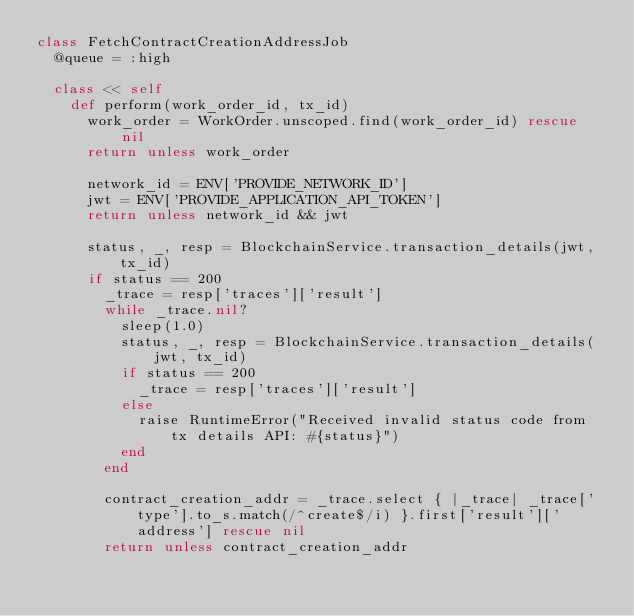<code> <loc_0><loc_0><loc_500><loc_500><_Ruby_>class FetchContractCreationAddressJob
  @queue = :high

  class << self
    def perform(work_order_id, tx_id)
      work_order = WorkOrder.unscoped.find(work_order_id) rescue nil
      return unless work_order

      network_id = ENV['PROVIDE_NETWORK_ID']
      jwt = ENV['PROVIDE_APPLICATION_API_TOKEN']
      return unless network_id && jwt

      status, _, resp = BlockchainService.transaction_details(jwt, tx_id)
      if status == 200
        _trace = resp['traces']['result']
        while _trace.nil?
          sleep(1.0)
          status, _, resp = BlockchainService.transaction_details(jwt, tx_id)
          if status == 200
            _trace = resp['traces']['result']
          else
            raise RuntimeError("Received invalid status code from tx details API: #{status}")
          end
        end

        contract_creation_addr = _trace.select { |_trace| _trace['type'].to_s.match(/^create$/i) }.first['result']['address'] rescue nil
        return unless contract_creation_addr
</code> 